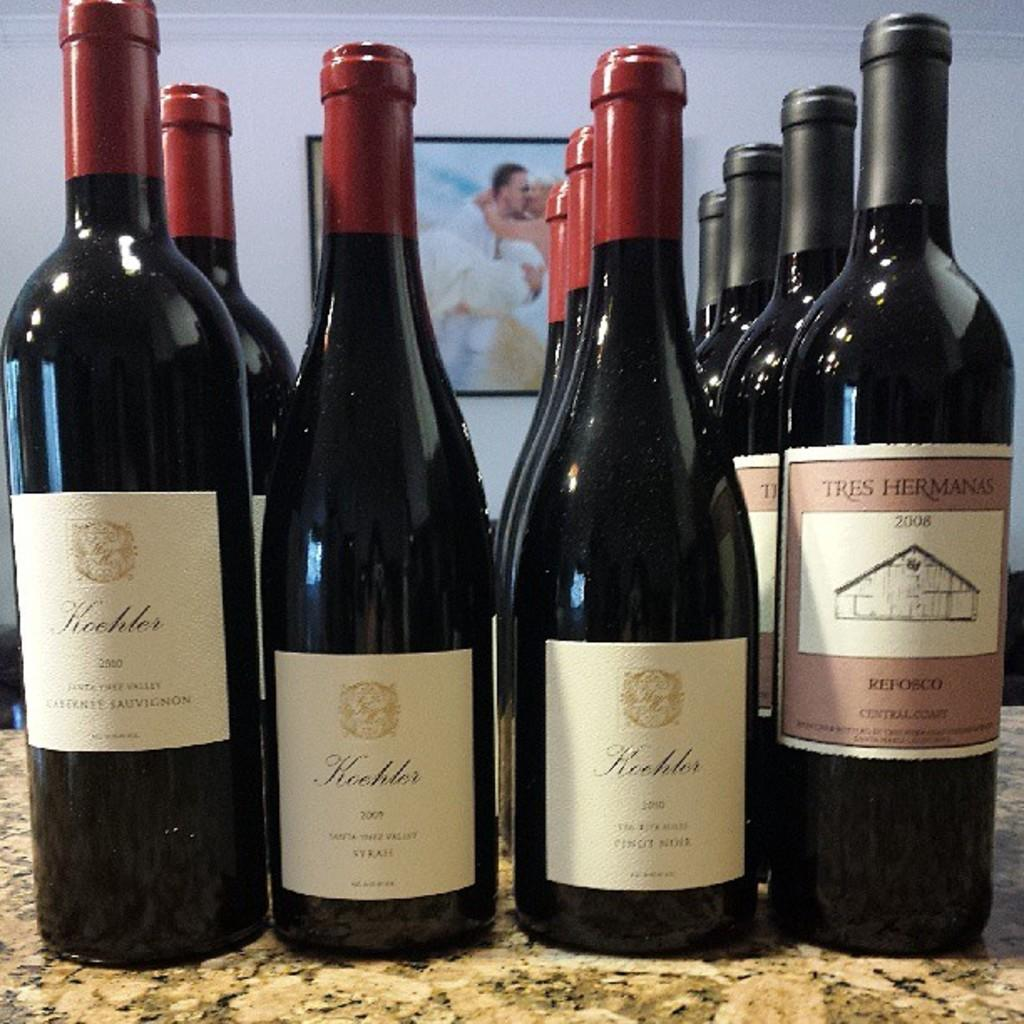<image>
Provide a brief description of the given image. Bottles of wine including one that says "Refosco" on the label. 